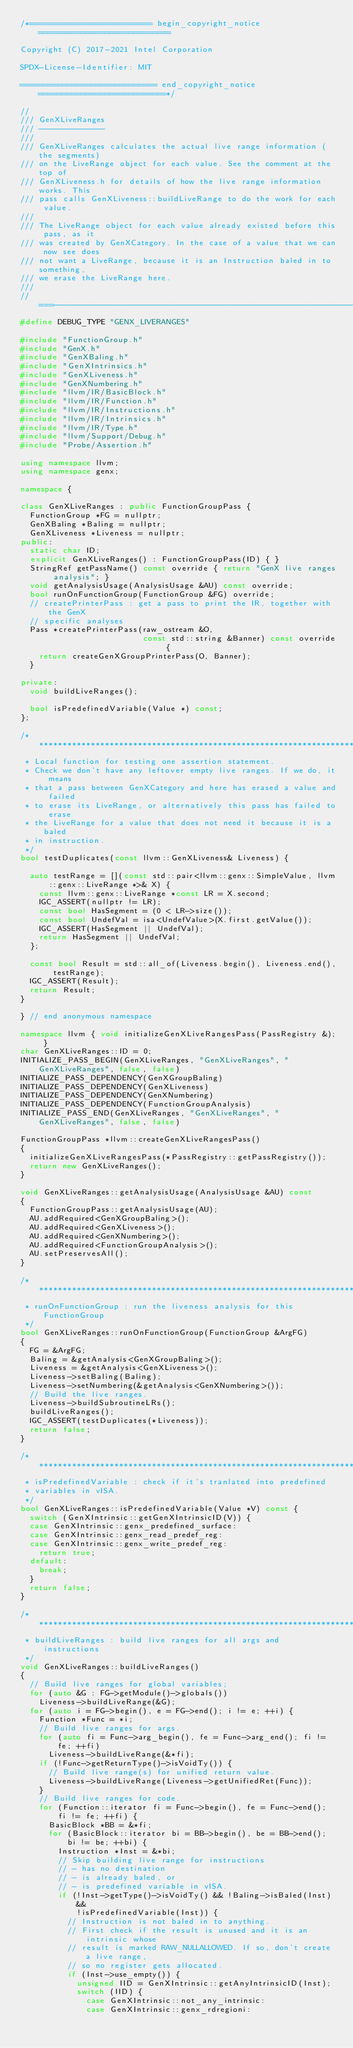<code> <loc_0><loc_0><loc_500><loc_500><_C++_>/*========================== begin_copyright_notice ============================

Copyright (C) 2017-2021 Intel Corporation

SPDX-License-Identifier: MIT

============================= end_copyright_notice ===========================*/

//
/// GenXLiveRanges
/// --------------
///
/// GenXLiveRanges calculates the actual live range information (the segments)
/// on the LiveRange object for each value. See the comment at the top of
/// GenXLiveness.h for details of how the live range information works. This
/// pass calls GenXLiveness::buildLiveRange to do the work for each value.
///
/// The LiveRange object for each value already existed before this pass, as it
/// was created by GenXCategory. In the case of a value that we can now see does
/// not want a LiveRange, because it is an Instruction baled in to something,
/// we erase the LiveRange here.
///
//===----------------------------------------------------------------------===//
#define DEBUG_TYPE "GENX_LIVERANGES"

#include "FunctionGroup.h"
#include "GenX.h"
#include "GenXBaling.h"
#include "GenXIntrinsics.h"
#include "GenXLiveness.h"
#include "GenXNumbering.h"
#include "llvm/IR/BasicBlock.h"
#include "llvm/IR/Function.h"
#include "llvm/IR/Instructions.h"
#include "llvm/IR/Intrinsics.h"
#include "llvm/IR/Type.h"
#include "llvm/Support/Debug.h"
#include "Probe/Assertion.h"

using namespace llvm;
using namespace genx;

namespace {

class GenXLiveRanges : public FunctionGroupPass {
  FunctionGroup *FG = nullptr;
  GenXBaling *Baling = nullptr;
  GenXLiveness *Liveness = nullptr;
public:
  static char ID;
  explicit GenXLiveRanges() : FunctionGroupPass(ID) { }
  StringRef getPassName() const override { return "GenX live ranges analysis"; }
  void getAnalysisUsage(AnalysisUsage &AU) const override;
  bool runOnFunctionGroup(FunctionGroup &FG) override;
  // createPrinterPass : get a pass to print the IR, together with the GenX
  // specific analyses
  Pass *createPrinterPass(raw_ostream &O,
                          const std::string &Banner) const override {
    return createGenXGroupPrinterPass(O, Banner);
  }

private:
  void buildLiveRanges();

  bool isPredefinedVariable(Value *) const;
};

/***********************************************************************
 * Local function for testing one assertion statement.
 * Check we don't have any leftover empty live ranges. If we do, it means
 * that a pass between GenXCategory and here has erased a value and failed
 * to erase its LiveRange, or alternatively this pass has failed to erase
 * the LiveRange for a value that does not need it because it is a baled
 * in instruction.
 */
bool testDuplicates(const llvm::GenXLiveness& Liveness) {

  auto testRange = [](const std::pair<llvm::genx::SimpleValue, llvm::genx::LiveRange *>& X) {
    const llvm::genx::LiveRange *const LR = X.second;
    IGC_ASSERT(nullptr != LR);
    const bool HasSegment = (0 < LR->size());
    const bool UndefVal = isa<UndefValue>(X.first.getValue());
    IGC_ASSERT(HasSegment || UndefVal);
    return HasSegment || UndefVal;
  };

  const bool Result = std::all_of(Liveness.begin(), Liveness.end(), testRange);
  IGC_ASSERT(Result);
  return Result;
}

} // end anonymous namespace

namespace llvm { void initializeGenXLiveRangesPass(PassRegistry &); }
char GenXLiveRanges::ID = 0;
INITIALIZE_PASS_BEGIN(GenXLiveRanges, "GenXLiveRanges", "GenXLiveRanges", false, false)
INITIALIZE_PASS_DEPENDENCY(GenXGroupBaling)
INITIALIZE_PASS_DEPENDENCY(GenXLiveness)
INITIALIZE_PASS_DEPENDENCY(GenXNumbering)
INITIALIZE_PASS_DEPENDENCY(FunctionGroupAnalysis)
INITIALIZE_PASS_END(GenXLiveRanges, "GenXLiveRanges", "GenXLiveRanges", false, false)

FunctionGroupPass *llvm::createGenXLiveRangesPass()
{
  initializeGenXLiveRangesPass(*PassRegistry::getPassRegistry());
  return new GenXLiveRanges();
}

void GenXLiveRanges::getAnalysisUsage(AnalysisUsage &AU) const
{
  FunctionGroupPass::getAnalysisUsage(AU);
  AU.addRequired<GenXGroupBaling>();
  AU.addRequired<GenXLiveness>();
  AU.addRequired<GenXNumbering>();
  AU.addRequired<FunctionGroupAnalysis>();
  AU.setPreservesAll();
}

/***********************************************************************
 * runOnFunctionGroup : run the liveness analysis for this FunctionGroup
 */
bool GenXLiveRanges::runOnFunctionGroup(FunctionGroup &ArgFG)
{
  FG = &ArgFG;
  Baling = &getAnalysis<GenXGroupBaling>();
  Liveness = &getAnalysis<GenXLiveness>();
  Liveness->setBaling(Baling);
  Liveness->setNumbering(&getAnalysis<GenXNumbering>());
  // Build the live ranges.
  Liveness->buildSubroutineLRs();
  buildLiveRanges();
  IGC_ASSERT(testDuplicates(*Liveness));
  return false;
}

/***********************************************************************
 * isPredefinedVariable : check if it's tranlated into predefined
 * variables in vISA.
 */
bool GenXLiveRanges::isPredefinedVariable(Value *V) const {
  switch (GenXIntrinsic::getGenXIntrinsicID(V)) {
  case GenXIntrinsic::genx_predefined_surface:
  case GenXIntrinsic::genx_read_predef_reg:
  case GenXIntrinsic::genx_write_predef_reg:
    return true;
  default:
    break;
  }
  return false;
}

/***********************************************************************
 * buildLiveRanges : build live ranges for all args and instructions
 */
void GenXLiveRanges::buildLiveRanges()
{
  // Build live ranges for global variables;
  for (auto &G : FG->getModule()->globals())
    Liveness->buildLiveRange(&G);
  for (auto i = FG->begin(), e = FG->end(); i != e; ++i) {
    Function *Func = *i;
    // Build live ranges for args.
    for (auto fi = Func->arg_begin(), fe = Func->arg_end(); fi != fe; ++fi)
      Liveness->buildLiveRange(&*fi);
    if (!Func->getReturnType()->isVoidTy()) {
      // Build live range(s) for unified return value.
      Liveness->buildLiveRange(Liveness->getUnifiedRet(Func));
    }
    // Build live ranges for code.
    for (Function::iterator fi = Func->begin(), fe = Func->end(); fi != fe; ++fi) {
      BasicBlock *BB = &*fi;
      for (BasicBlock::iterator bi = BB->begin(), be = BB->end(); bi != be; ++bi) {
        Instruction *Inst = &*bi;
        // Skip building live range for instructions
        // - has no destination
        // - is already baled, or
        // - is predefined variable in vISA.
        if (!Inst->getType()->isVoidTy() && !Baling->isBaled(Inst) &&
            !isPredefinedVariable(Inst)) {
          // Instruction is not baled in to anything.
          // First check if the result is unused and it is an intrinsic whose
          // result is marked RAW_NULLALLOWED. If so, don't create a live range,
          // so no register gets allocated.
          if (Inst->use_empty()) {
            unsigned IID = GenXIntrinsic::getAnyIntrinsicID(Inst);
            switch (IID) {
              case GenXIntrinsic::not_any_intrinsic:
              case GenXIntrinsic::genx_rdregioni:</code> 